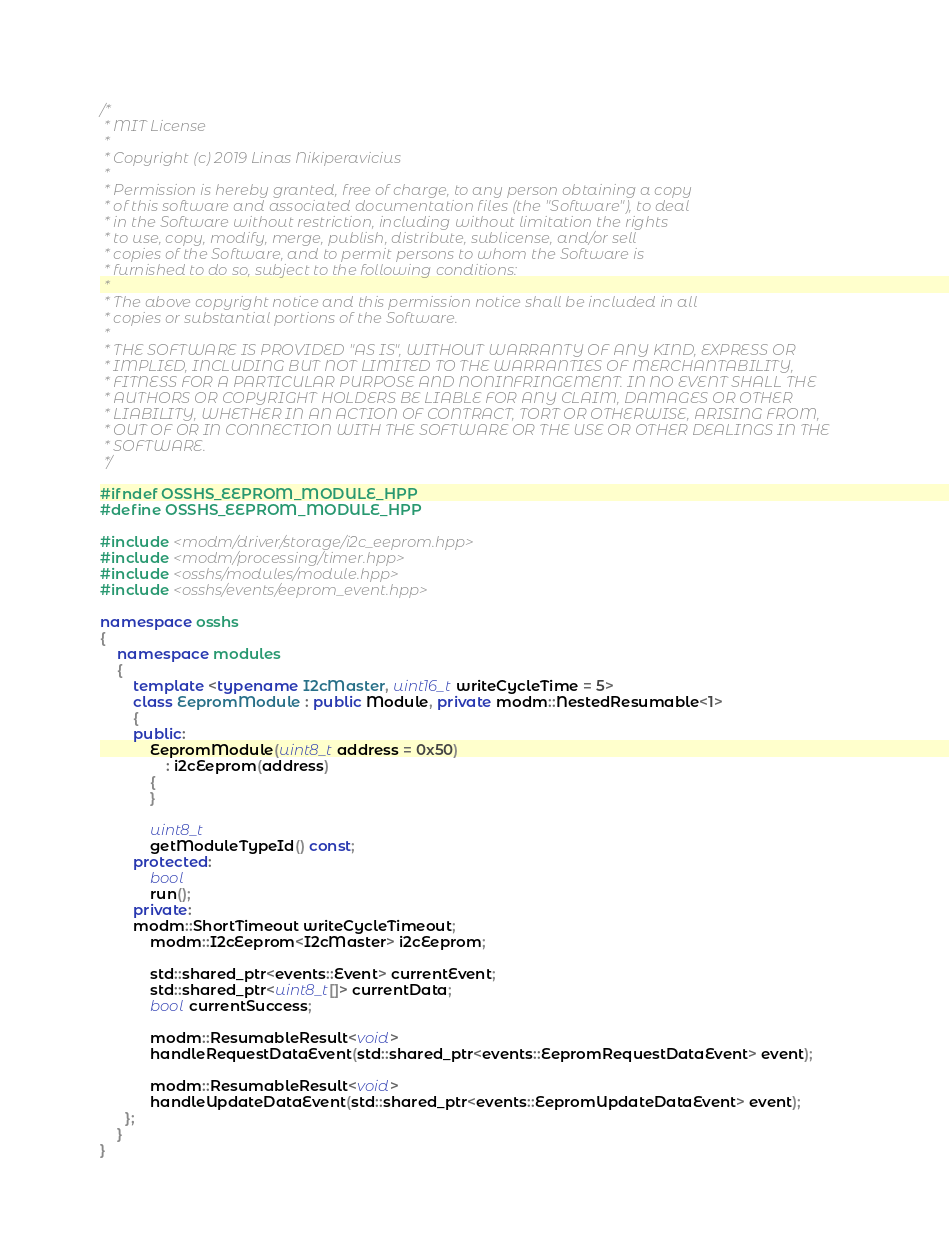Convert code to text. <code><loc_0><loc_0><loc_500><loc_500><_C++_>/*
 * MIT License
 *
 * Copyright (c) 2019 Linas Nikiperavicius
 *
 * Permission is hereby granted, free of charge, to any person obtaining a copy
 * of this software and associated documentation files (the "Software"), to deal
 * in the Software without restriction, including without limitation the rights
 * to use, copy, modify, merge, publish, distribute, sublicense, and/or sell
 * copies of the Software, and to permit persons to whom the Software is
 * furnished to do so, subject to the following conditions:
 *
 * The above copyright notice and this permission notice shall be included in all
 * copies or substantial portions of the Software.
 *
 * THE SOFTWARE IS PROVIDED "AS IS", WITHOUT WARRANTY OF ANY KIND, EXPRESS OR
 * IMPLIED, INCLUDING BUT NOT LIMITED TO THE WARRANTIES OF MERCHANTABILITY,
 * FITNESS FOR A PARTICULAR PURPOSE AND NONINFRINGEMENT. IN NO EVENT SHALL THE
 * AUTHORS OR COPYRIGHT HOLDERS BE LIABLE FOR ANY CLAIM, DAMAGES OR OTHER
 * LIABILITY, WHETHER IN AN ACTION OF CONTRACT, TORT OR OTHERWISE, ARISING FROM,
 * OUT OF OR IN CONNECTION WITH THE SOFTWARE OR THE USE OR OTHER DEALINGS IN THE
 * SOFTWARE.
 */

#ifndef OSSHS_EEPROM_MODULE_HPP
#define OSSHS_EEPROM_MODULE_HPP

#include <modm/driver/storage/i2c_eeprom.hpp>
#include <modm/processing/timer.hpp>
#include <osshs/modules/module.hpp>
#include <osshs/events/eeprom_event.hpp>

namespace osshs
{
	namespace modules
	{
 		template <typename I2cMaster, uint16_t writeCycleTime = 5>
		class EepromModule : public Module, private modm::NestedResumable<1>
		{
		public:
			EepromModule(uint8_t address = 0x50)
				: i2cEeprom(address)
			{
			}

			uint8_t
			getModuleTypeId() const;
		protected:
			bool
			run();
		private:
    	modm::ShortTimeout writeCycleTimeout;
			modm::I2cEeprom<I2cMaster> i2cEeprom;

			std::shared_ptr<events::Event> currentEvent;
			std::shared_ptr<uint8_t[]> currentData;
			bool currentSuccess;

			modm::ResumableResult<void>
			handleRequestDataEvent(std::shared_ptr<events::EepromRequestDataEvent> event);

			modm::ResumableResult<void>
			handleUpdateDataEvent(std::shared_ptr<events::EepromUpdateDataEvent> event);
	  };
	}
}
</code> 